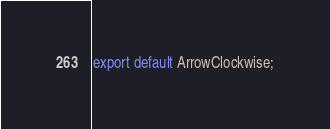<code> <loc_0><loc_0><loc_500><loc_500><_TypeScript_>export default ArrowClockwise;
</code> 